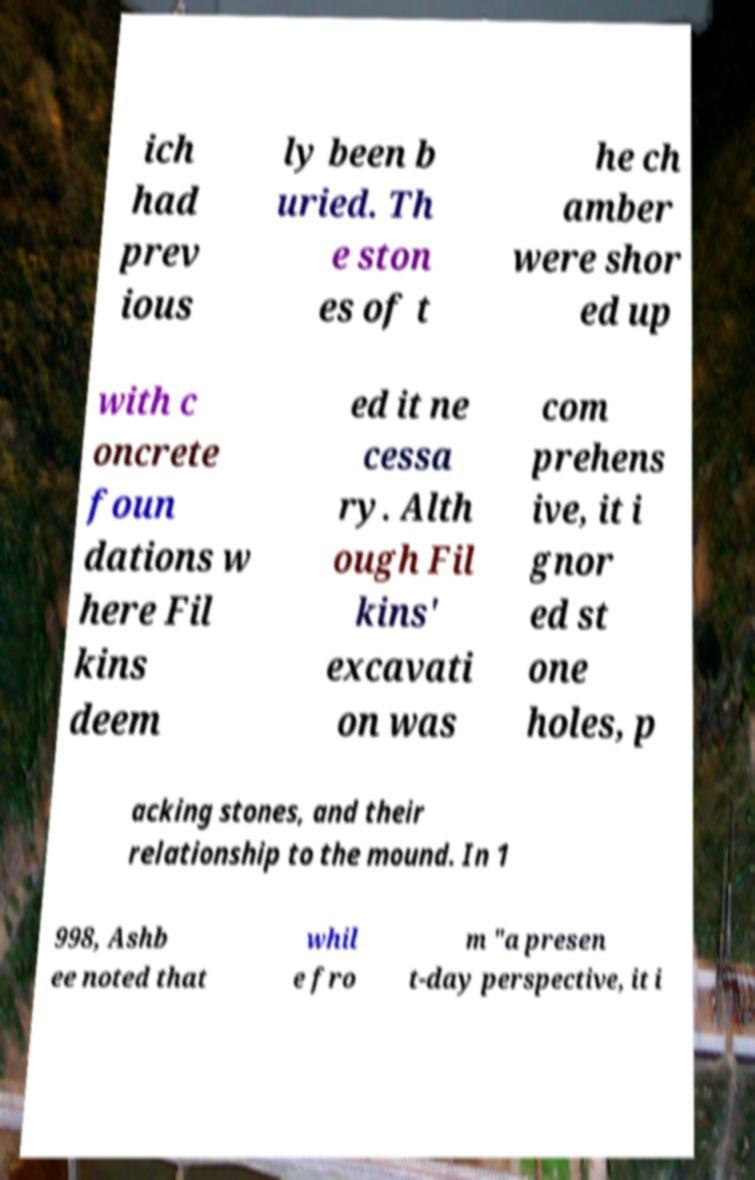Can you read and provide the text displayed in the image?This photo seems to have some interesting text. Can you extract and type it out for me? ich had prev ious ly been b uried. Th e ston es of t he ch amber were shor ed up with c oncrete foun dations w here Fil kins deem ed it ne cessa ry. Alth ough Fil kins' excavati on was com prehens ive, it i gnor ed st one holes, p acking stones, and their relationship to the mound. In 1 998, Ashb ee noted that whil e fro m "a presen t-day perspective, it i 